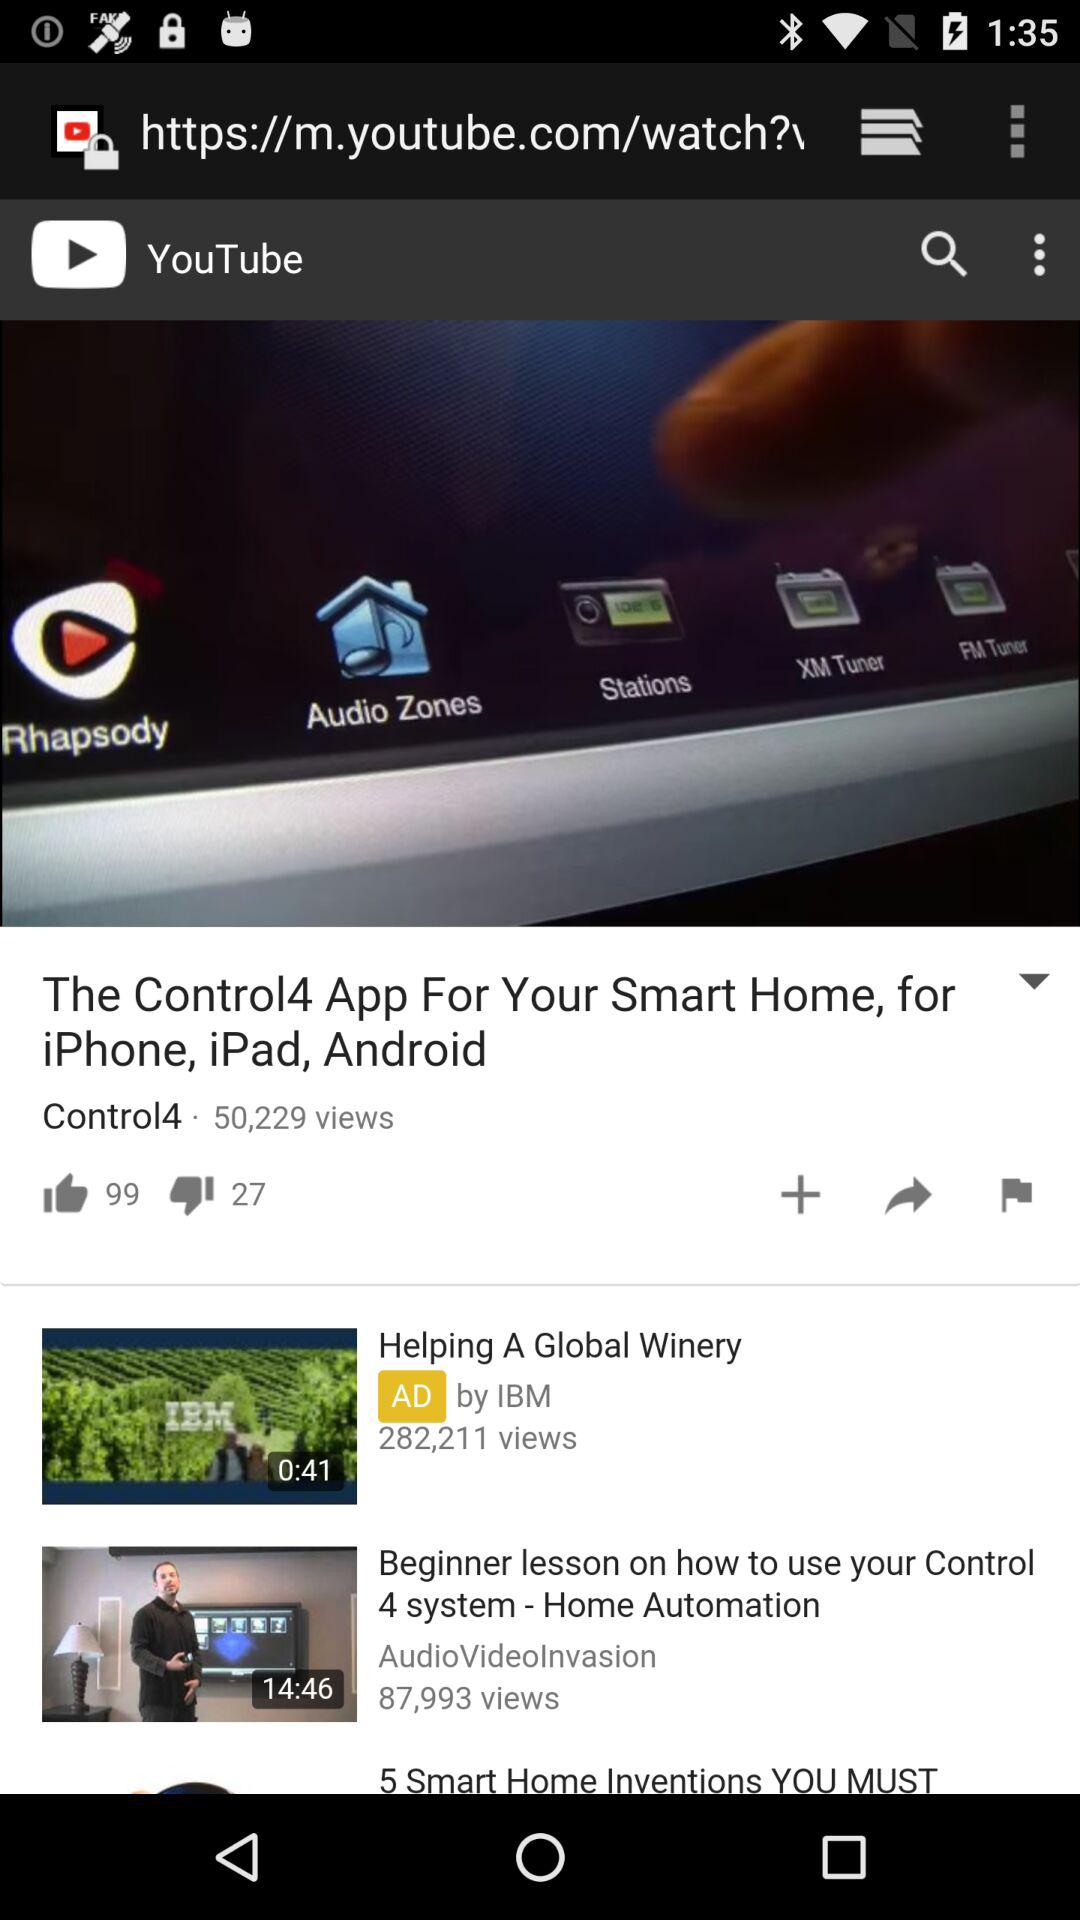What is the title of the video? The titles of the videos are "The Control4 App For Your Smart Home, for iPhone, iPad, Android", "Helping A Global Winery" and "Beginner lesson on how to use your Control 4 system - Home Automation". 